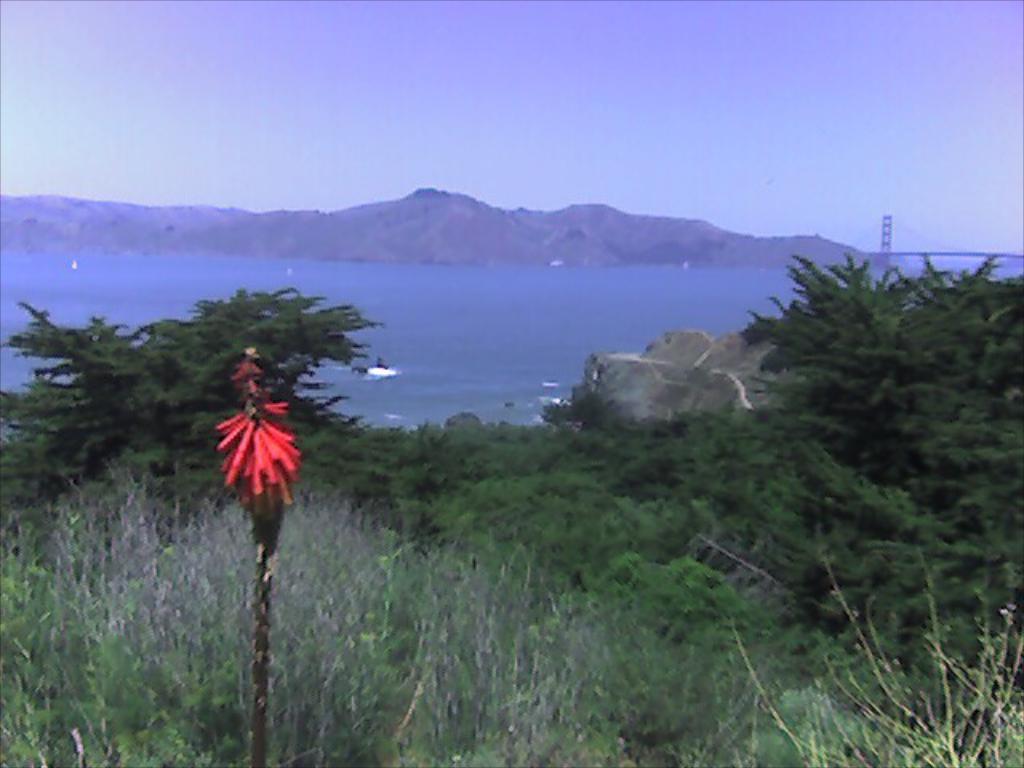In one or two sentences, can you explain what this image depicts? In this image I can see trees,water,mountains,rock and bridge. I can see red and black color object in front. The sky is in blue and white color. 